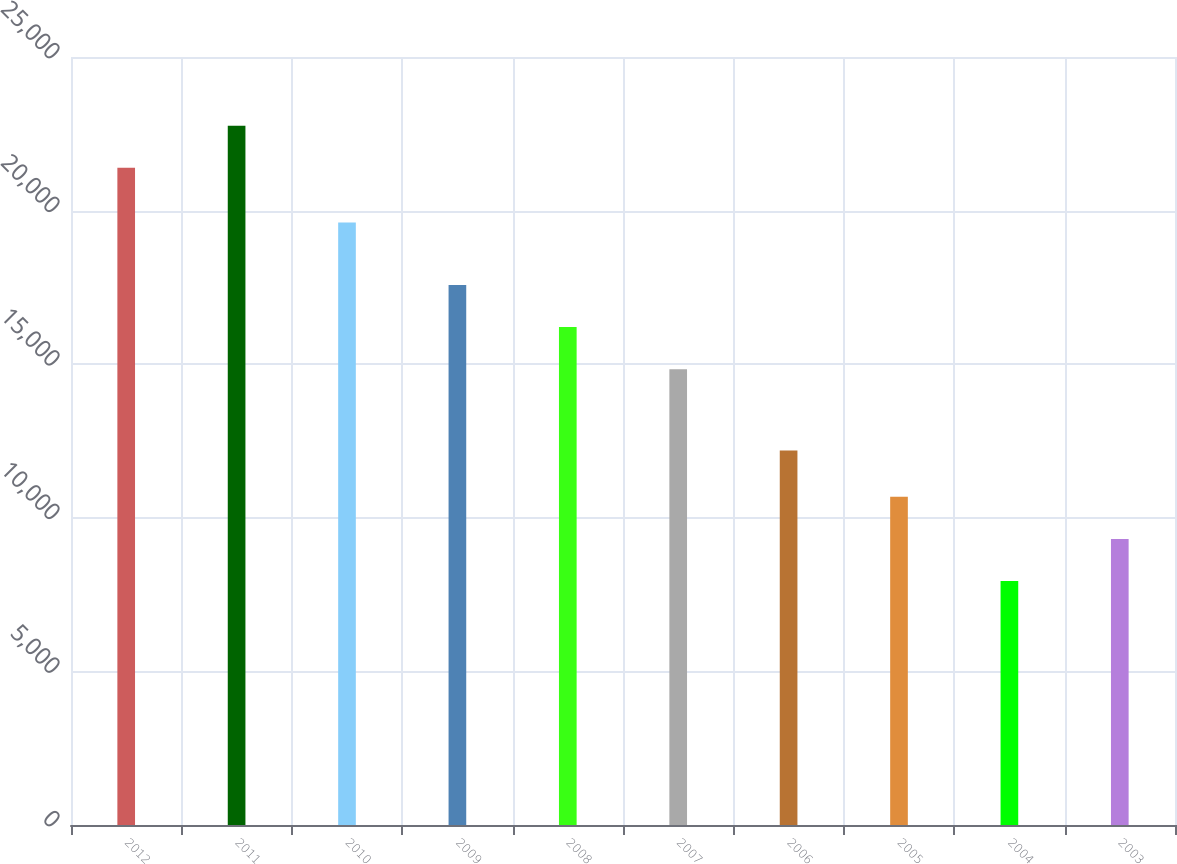<chart> <loc_0><loc_0><loc_500><loc_500><bar_chart><fcel>2012<fcel>2011<fcel>2010<fcel>2009<fcel>2008<fcel>2007<fcel>2006<fcel>2005<fcel>2004<fcel>2003<nl><fcel>21393<fcel>22764.1<fcel>19612<fcel>17578.2<fcel>16207.1<fcel>14836<fcel>12189<fcel>10683.2<fcel>7941<fcel>9312.1<nl></chart> 